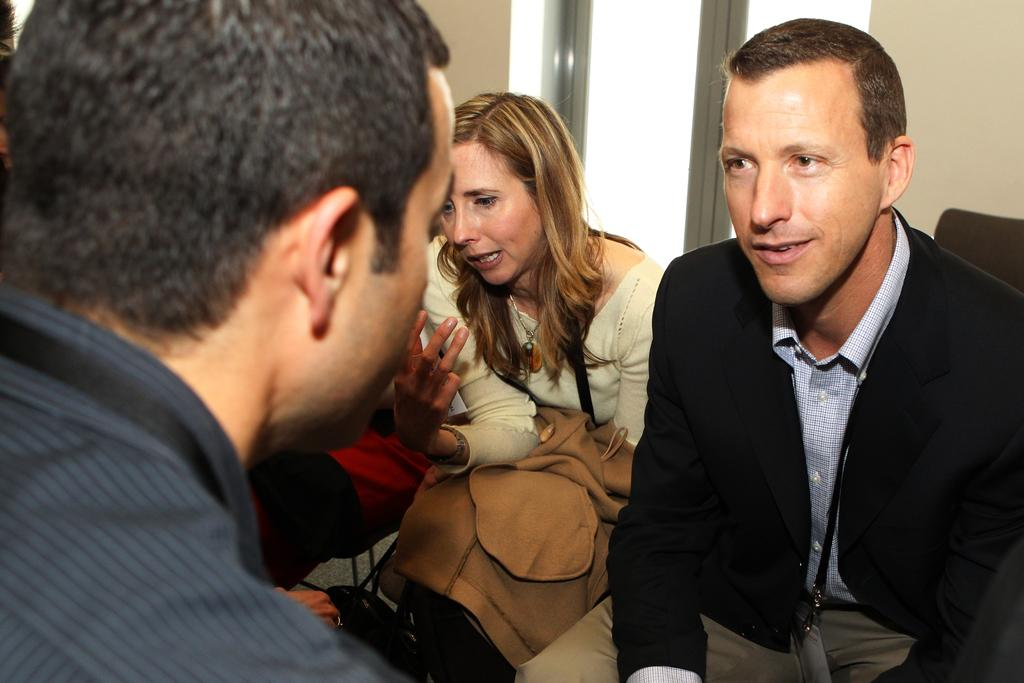How many people are in the image? There are three people in the image. What are the people doing in the image? The people are sitting and talking to each other. Can you describe any architectural features in the image? Yes, there is a window with a glass door and a wall in the image. What type of organization is depicted on the wall in the image? There is no organization depicted on the wall in the image; it only shows a wall and a window with a glass door. What time is it according to the clock in the image? There is no clock present in the image. 